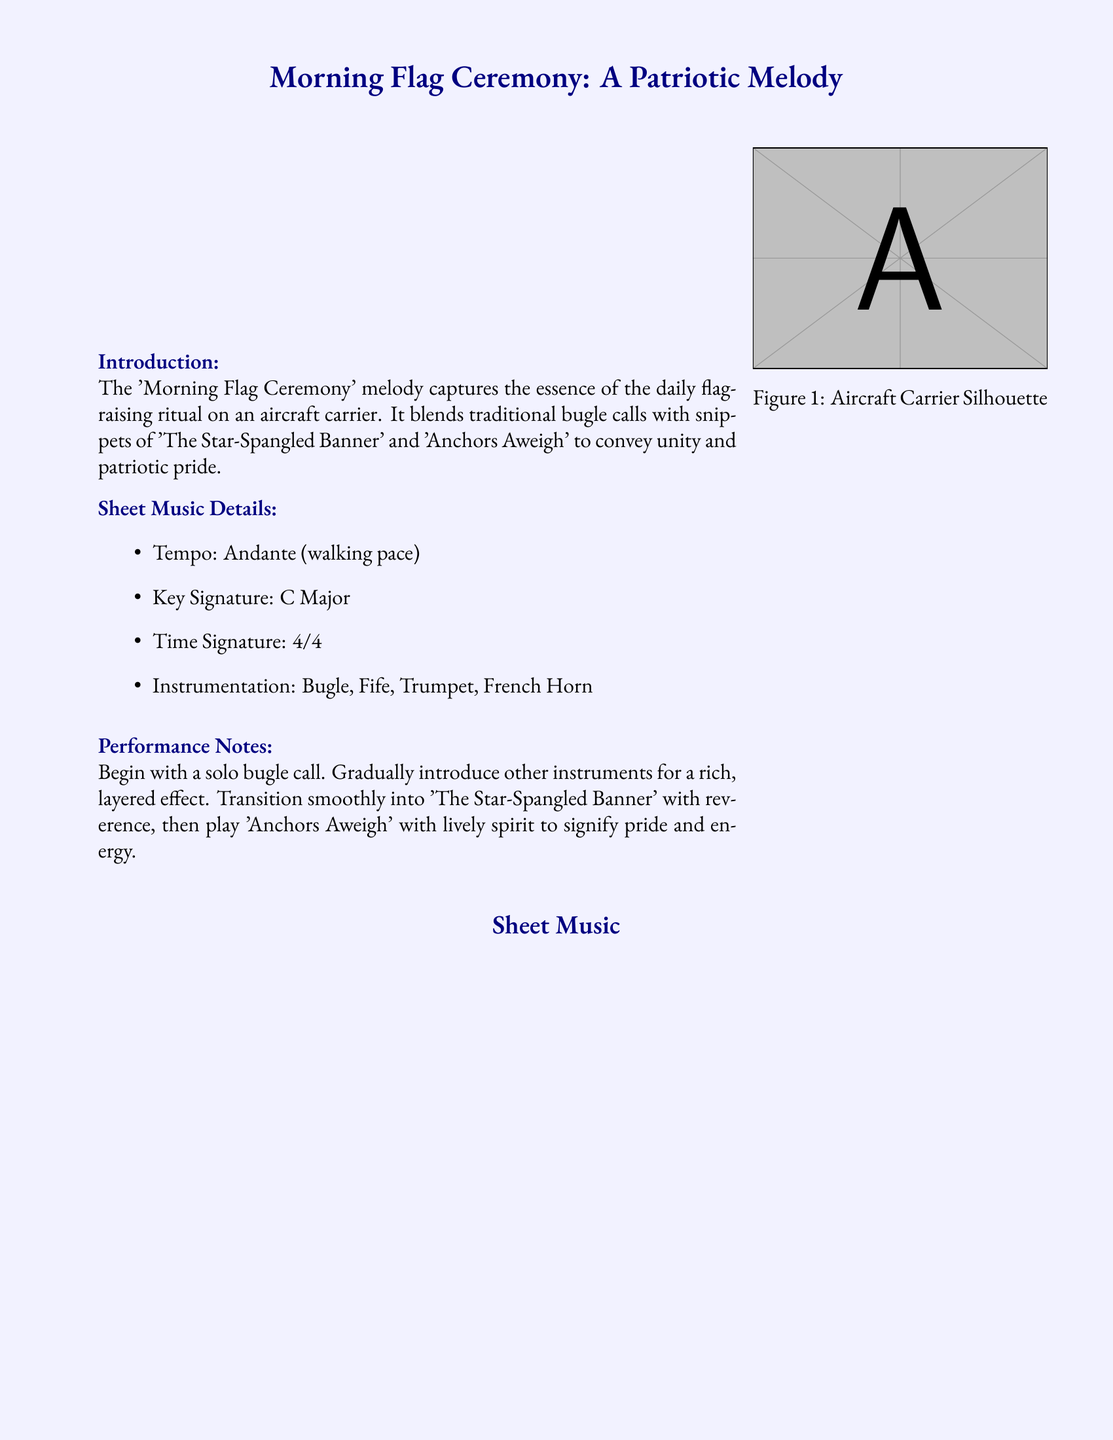What is the title of the sheet music? The title is prominently featured at the top of the document, indicating the piece of music.
Answer: Morning Flag Ceremony: A Patriotic Melody What instruments are included in the sheet music? The instruments are listed under the sheet music details section.
Answer: Bugle, Fife, Trumpet, French Horn What is the tempo of the piece? The tempo is stated in the sheet music details section.
Answer: Andante What is the key signature of the melody? The key signature is specified in the sheet music details section.
Answer: C Major What is the time signature used in the music? The time signature is mentioned in the sheet music details section.
Answer: 4/4 What is the intended starting instrument for the performance? The performance notes indicate the first instrument to be used.
Answer: Solo bugle Which national anthem is referenced in the melody? The sheet music mentions a national anthem as part of its description.
Answer: The Star-Spangled Banner What does the ceremony symbolize for sailors? The historical context explains the significance of the ceremony for service members.
Answer: National values and service honor What is the final note in the document? The final phrase of the document highlights the Navy's core values.
Answer: Honor, Courage, Commitment 